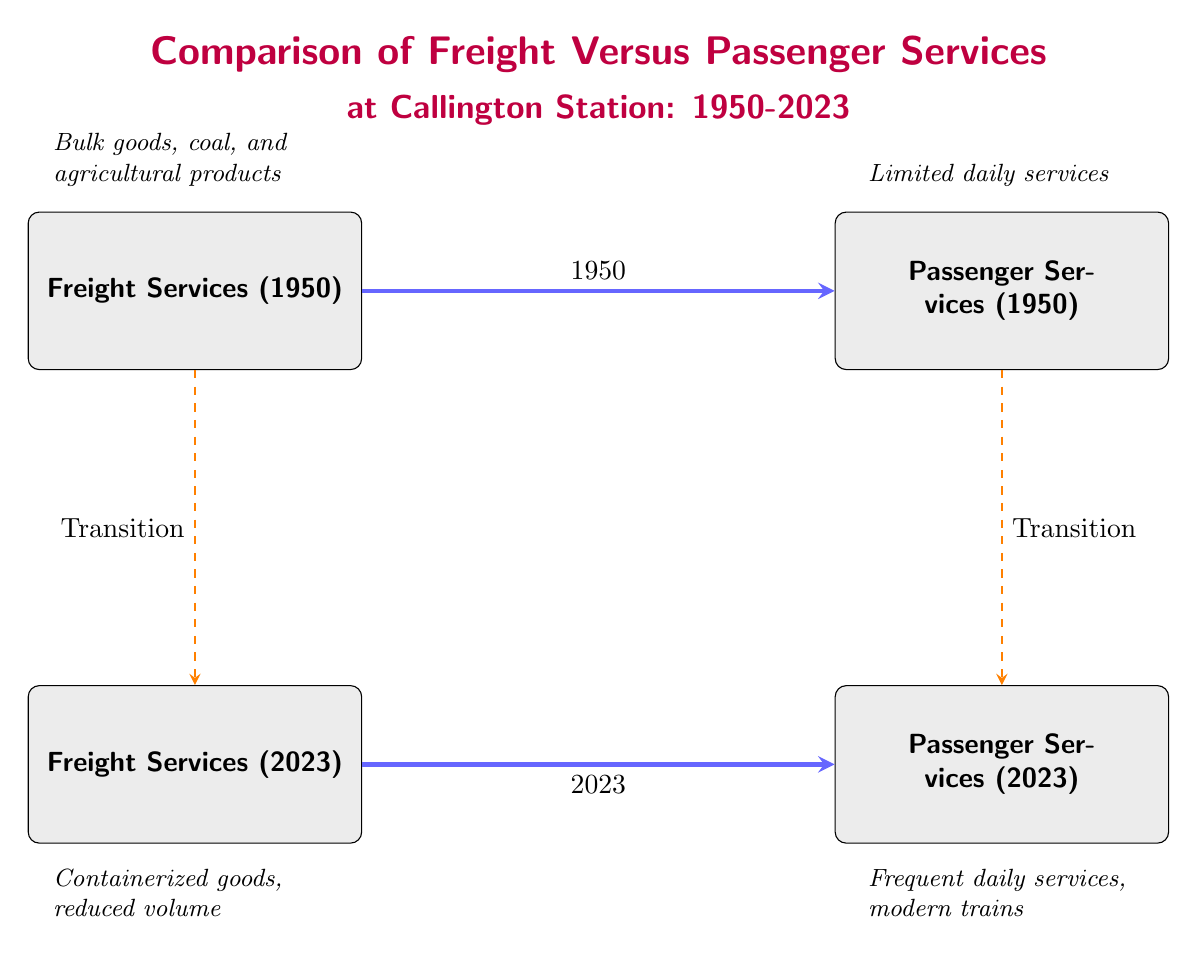What services were present in 1950? The diagram shows two nodes for the year 1950 at the top: "Freight Services (1950)" and "Passenger Services (1950)." The label clearly indicates that both services were available during that year.
Answer: Freight and Passenger Services What type of goods were transported in 1950 freight services? The annotation linked to the "Freight Services (1950)" node states "Bulk goods, coal, and agricultural products." This provides a clear description of the types of goods transported during that time.
Answer: Bulk goods, coal, and agricultural products What can be observed about passenger services in 2023 compared to 1950? From the annotations and nodes, the "Passenger Services (2023)" node states "Frequent daily services, modern trains," while "Passenger Services (1950)" shows "Limited daily services." This indicates a significant improvement in frequency and modernization.
Answer: Frequent daily services, modern trains How many transition arrows are shown in the diagram? There are two transition arrows: one from "Freight Services (1950)" to "Freight Services (2023)" and another from "Passenger Services (1950)" to "Passenger Services (2023)." Counting these provides the total number of transition arrows.
Answer: 2 What type of goods are transported in 2023 freight services? The annotation associated with "Freight Services (2023)" indicates "Containerized goods, reduced volume." This succinctly describes the nature of freight services in the present day.
Answer: Containerized goods, reduced volume Which transition indicates a change in passenger services? The transition arrow illustrates a shift from "Passenger Services (1950)" to "Passenger Services (2023)," indicating the improvements in passenger services over the years.
Answer: Passenger Services Transition What does the year 1950 represent in the diagram? The year 1950 serves as a reference point in the diagram for both freight and passenger services, denoting the historical context in comparison to modern services in 2023.
Answer: Historical reference What does the color of the boxes signify in the diagram? The light gray fill of the boxes likely signifies that they represent different service types at Callington Station. The uniform color indicates a category rather than functional or performance differences.
Answer: Service type category 